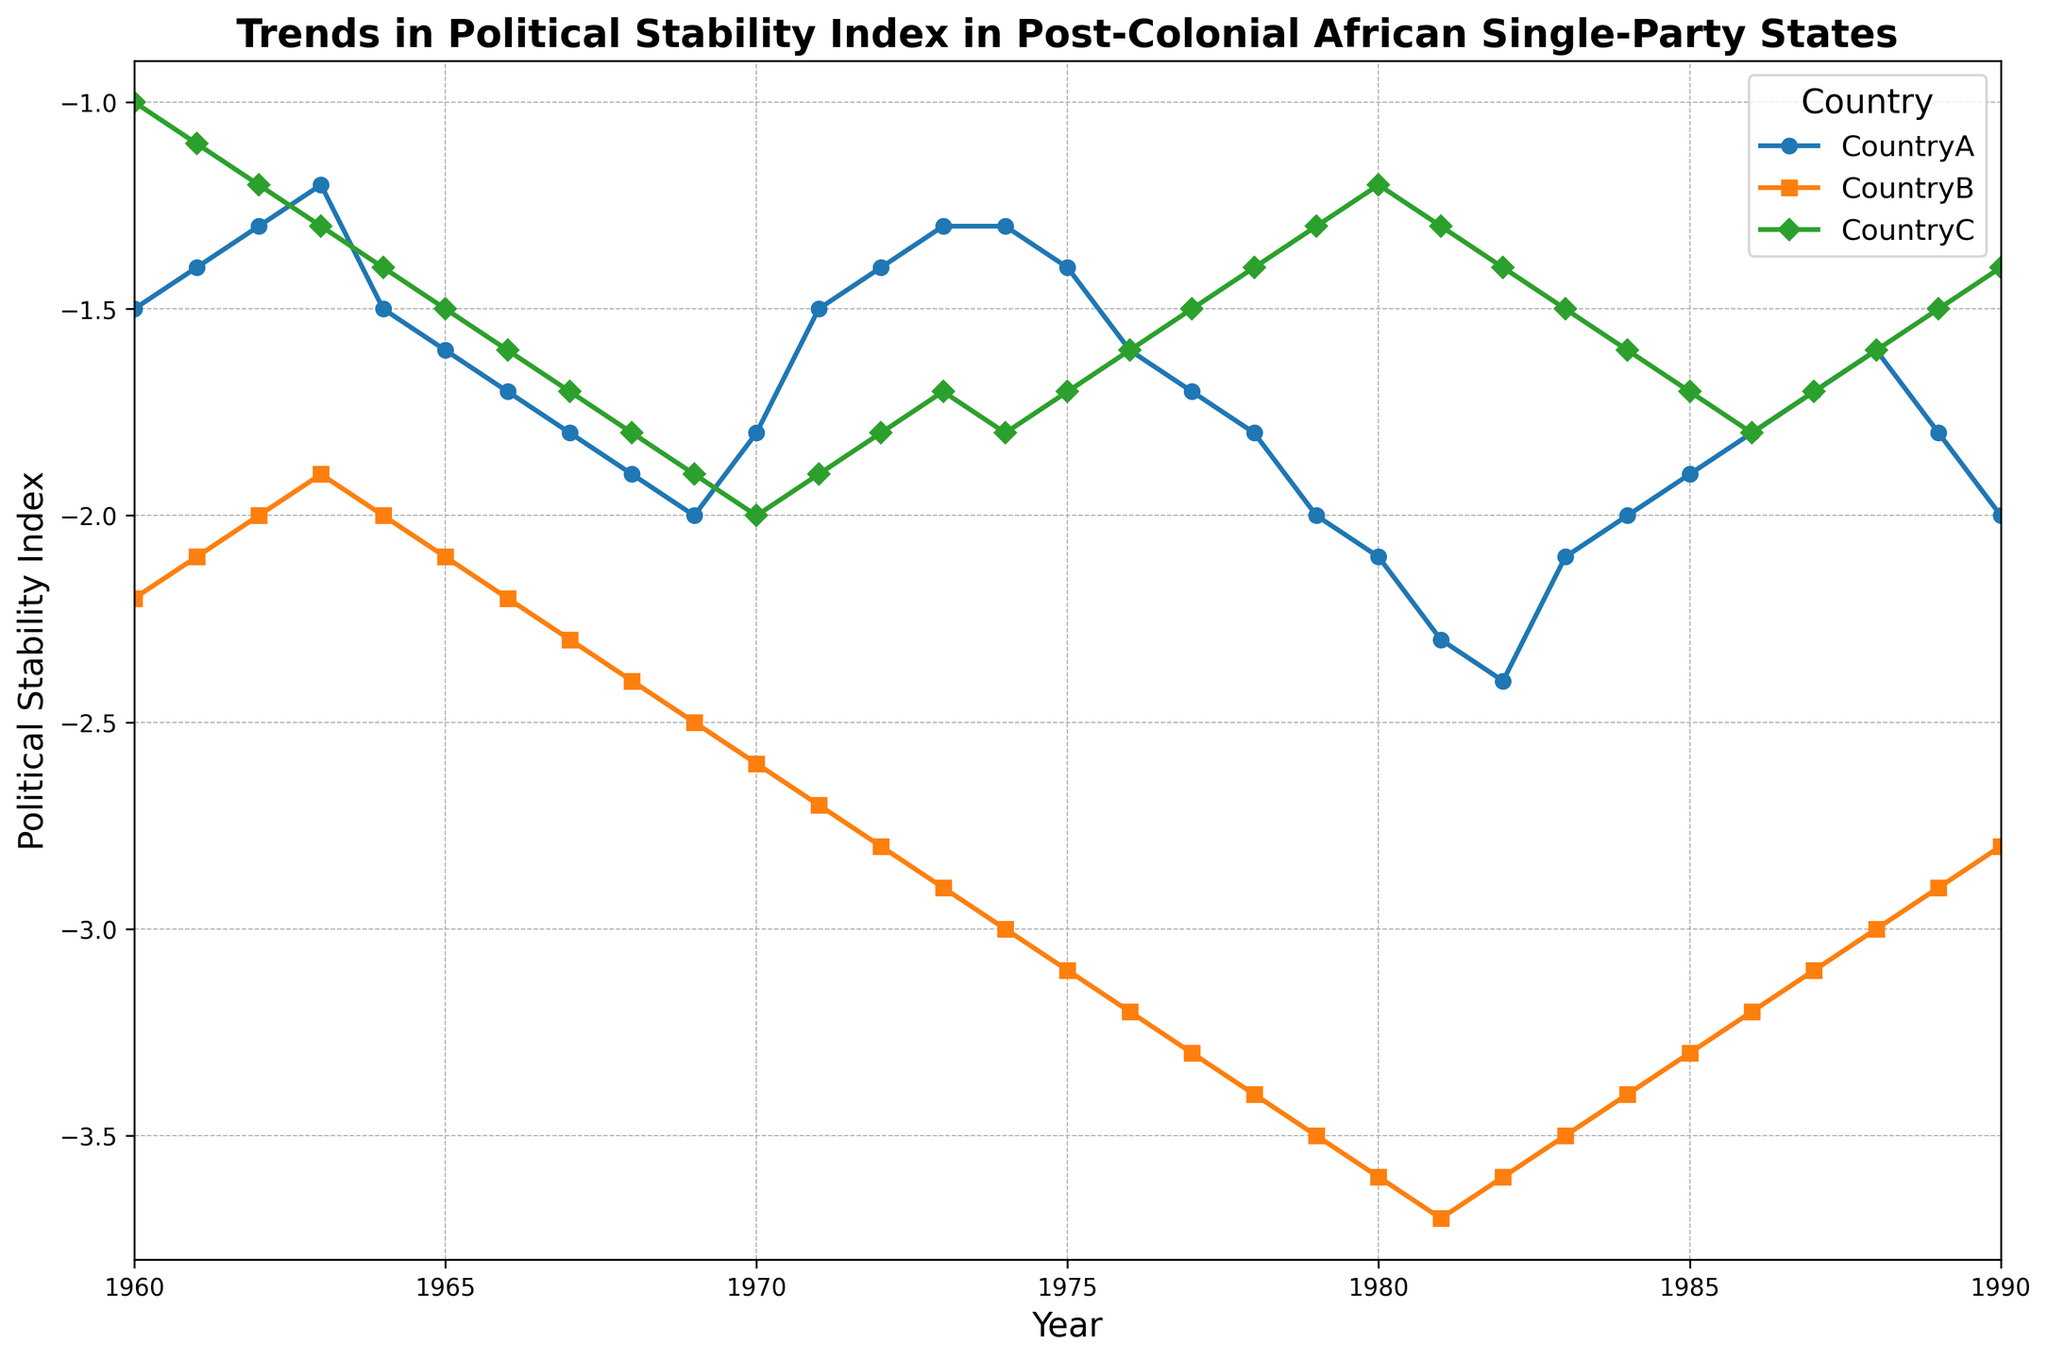What is the overall trend in the Political Stability Index for CountryA from 1960 to 1990? From the line graph for CountryA, observe that the Political Stability Index generally decreases over time, with some fluctuations. It starts at -1.5 in 1960, fluctuates between -1.3 and -2.4, and ends at -2.0 in 1990.
Answer: Generally decreasing Between which years does CountryB experience the most significant decline in Political Stability Index? To find this, observe the steepest downward slope on CountryB's line graph. The steepest decline is from 1969 to 1970 where the index drops from -2.5 to -2.6.
Answer: 1969 to 1970 Which country showed a temporary increase in Political Stability Index around the mid-1980s? By comparing the line graphs for the three countries, observe that CountryA's line shows a rise in the Political Stability Index around 1983 and 1984, where it increases from -2.4 to -2.0.
Answer: CountryA Around what year did CountryC's Political Stability Index start to improve again after a period of decline? To find this, observe CountryC's line for the point where it stops declining and starts increasing. This happens around 1970 when the index increases from -2.0 to -1.9 the following year.
Answer: Around 1970 How much did the Political Stability Index for CountryB decline from 1960 to 1970? To find this, subtract the 1970 value from the 1960 value for CountryB. The values are -2.6 (1970) and -2.2 (1960), so the decline is -2.6 - (-2.2) = -0.4.
Answer: 0.4 Compare the Political Stability Index values for the three countries in the year 1980. Which country had the highest and which had the lowest index? Look at the index values in 1980 for each country: CountryA is -2.1, CountryB is -3.6, and CountryC is -1.2. CountryC has the highest index and CountryB has the lowest.
Answer: Highest: CountryC, Lowest: CountryB Which country experienced the most stable Political Stability Index over the given period? To determine this, observe the line graphs for fluctuations. CountryC's line shows the smallest fluctuations compared to CountryA and CountryB.
Answer: CountryC What is the approximate average Political Stability Index of CountryC from 1980 to 1990? Calculate the average using the values from the line graph for CountryC from 1980 to 1990: (-1.2 -1.3 -1.4 -1.5 -1.6 -1.7 -1.8 -1.7 -1.6 -1.5 -1.4). Sum these values and divide by the number of years (11). The sum is -15.1, so the average is -15.1 / 11 ≈ -1.37.
Answer: Approximately -1.37 Which country showed the steepest overall decline in Political Stability Index, and what was the magnitude of the decline? Observe the overall change from 1960 to 1990 for each country. CountryB declines from -2.2 to -2.8 (decline of -2.6), CountryA from -1.5 to -2.0 (decline of -0.5), and CountryC from -1.0 to -1.4 (decline of -0.4). The steepest decline occurs in CountryB with a magnitude of -2.6.
Answer: CountryB, 2.6 